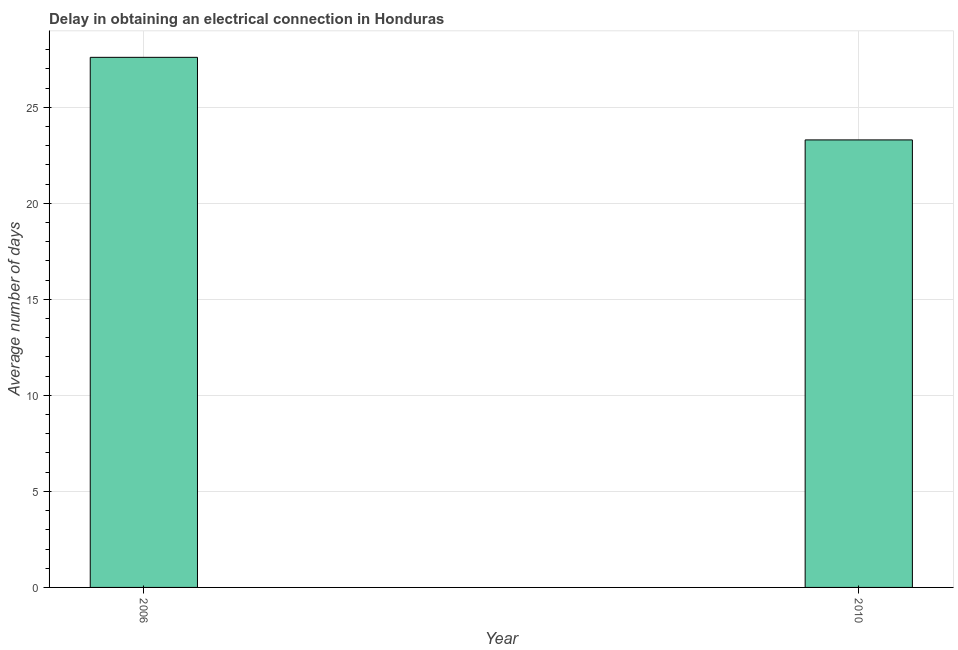Does the graph contain grids?
Provide a short and direct response. Yes. What is the title of the graph?
Your response must be concise. Delay in obtaining an electrical connection in Honduras. What is the label or title of the Y-axis?
Your answer should be very brief. Average number of days. What is the dalay in electrical connection in 2006?
Give a very brief answer. 27.6. Across all years, what is the maximum dalay in electrical connection?
Provide a short and direct response. 27.6. Across all years, what is the minimum dalay in electrical connection?
Your response must be concise. 23.3. In which year was the dalay in electrical connection maximum?
Ensure brevity in your answer.  2006. In which year was the dalay in electrical connection minimum?
Ensure brevity in your answer.  2010. What is the sum of the dalay in electrical connection?
Provide a succinct answer. 50.9. What is the average dalay in electrical connection per year?
Keep it short and to the point. 25.45. What is the median dalay in electrical connection?
Ensure brevity in your answer.  25.45. What is the ratio of the dalay in electrical connection in 2006 to that in 2010?
Keep it short and to the point. 1.19. In how many years, is the dalay in electrical connection greater than the average dalay in electrical connection taken over all years?
Provide a succinct answer. 1. How many bars are there?
Offer a terse response. 2. Are all the bars in the graph horizontal?
Your response must be concise. No. How many years are there in the graph?
Provide a short and direct response. 2. What is the Average number of days in 2006?
Keep it short and to the point. 27.6. What is the Average number of days of 2010?
Your answer should be compact. 23.3. What is the ratio of the Average number of days in 2006 to that in 2010?
Your answer should be very brief. 1.19. 